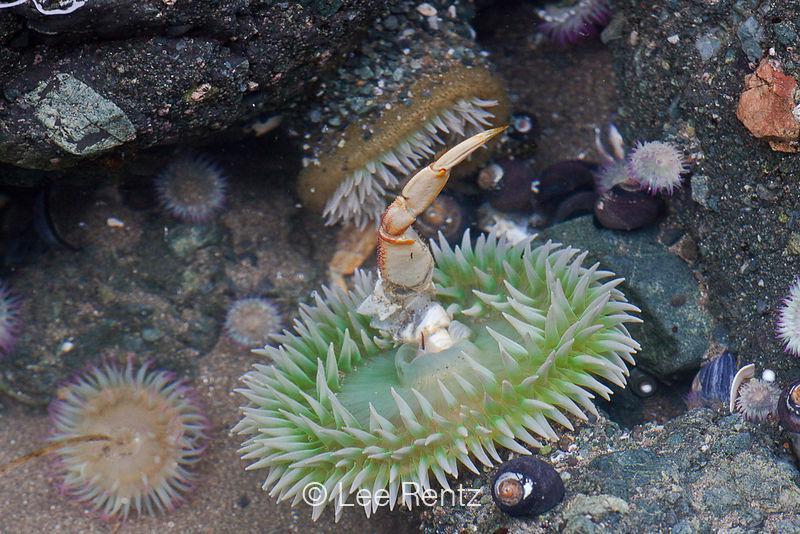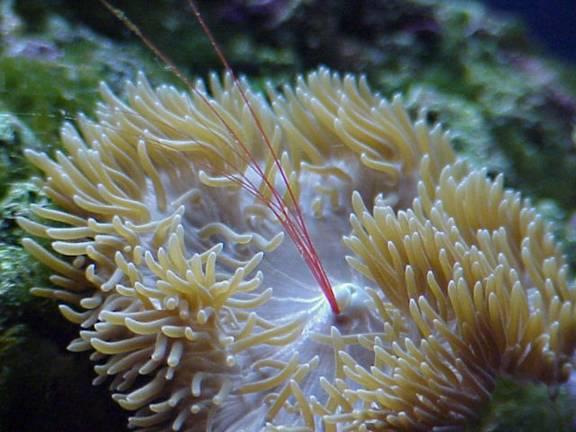The first image is the image on the left, the second image is the image on the right. For the images shown, is this caption "There is a crab inside an anemone." true? Answer yes or no. Yes. The first image is the image on the left, the second image is the image on the right. Examine the images to the left and right. Is the description "An image shows multiple fish with yellow coloration swimming near a large anemone." accurate? Answer yes or no. No. 